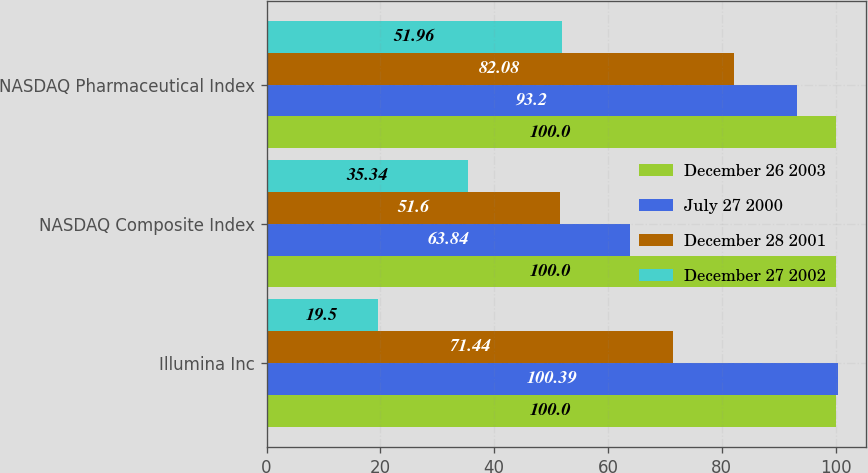Convert chart to OTSL. <chart><loc_0><loc_0><loc_500><loc_500><stacked_bar_chart><ecel><fcel>Illumina Inc<fcel>NASDAQ Composite Index<fcel>NASDAQ Pharmaceutical Index<nl><fcel>December 26 2003<fcel>100<fcel>100<fcel>100<nl><fcel>July 27 2000<fcel>100.39<fcel>63.84<fcel>93.2<nl><fcel>December 28 2001<fcel>71.44<fcel>51.6<fcel>82.08<nl><fcel>December 27 2002<fcel>19.5<fcel>35.34<fcel>51.96<nl></chart> 